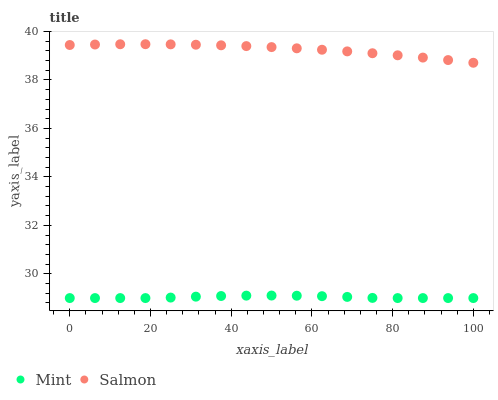Does Mint have the minimum area under the curve?
Answer yes or no. Yes. Does Salmon have the maximum area under the curve?
Answer yes or no. Yes. Does Mint have the maximum area under the curve?
Answer yes or no. No. Is Salmon the smoothest?
Answer yes or no. Yes. Is Mint the roughest?
Answer yes or no. Yes. Is Mint the smoothest?
Answer yes or no. No. Does Mint have the lowest value?
Answer yes or no. Yes. Does Salmon have the highest value?
Answer yes or no. Yes. Does Mint have the highest value?
Answer yes or no. No. Is Mint less than Salmon?
Answer yes or no. Yes. Is Salmon greater than Mint?
Answer yes or no. Yes. Does Mint intersect Salmon?
Answer yes or no. No. 